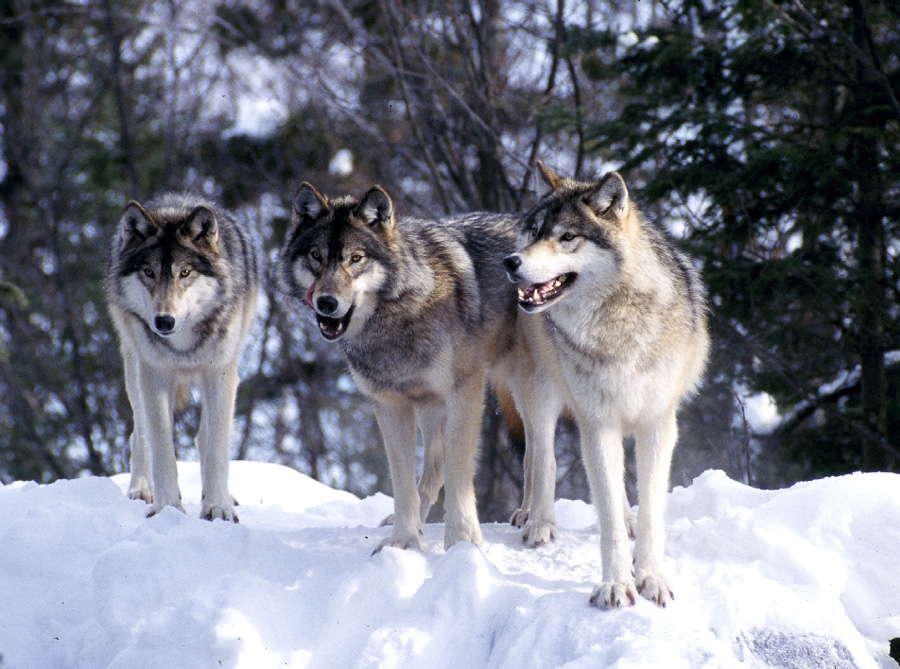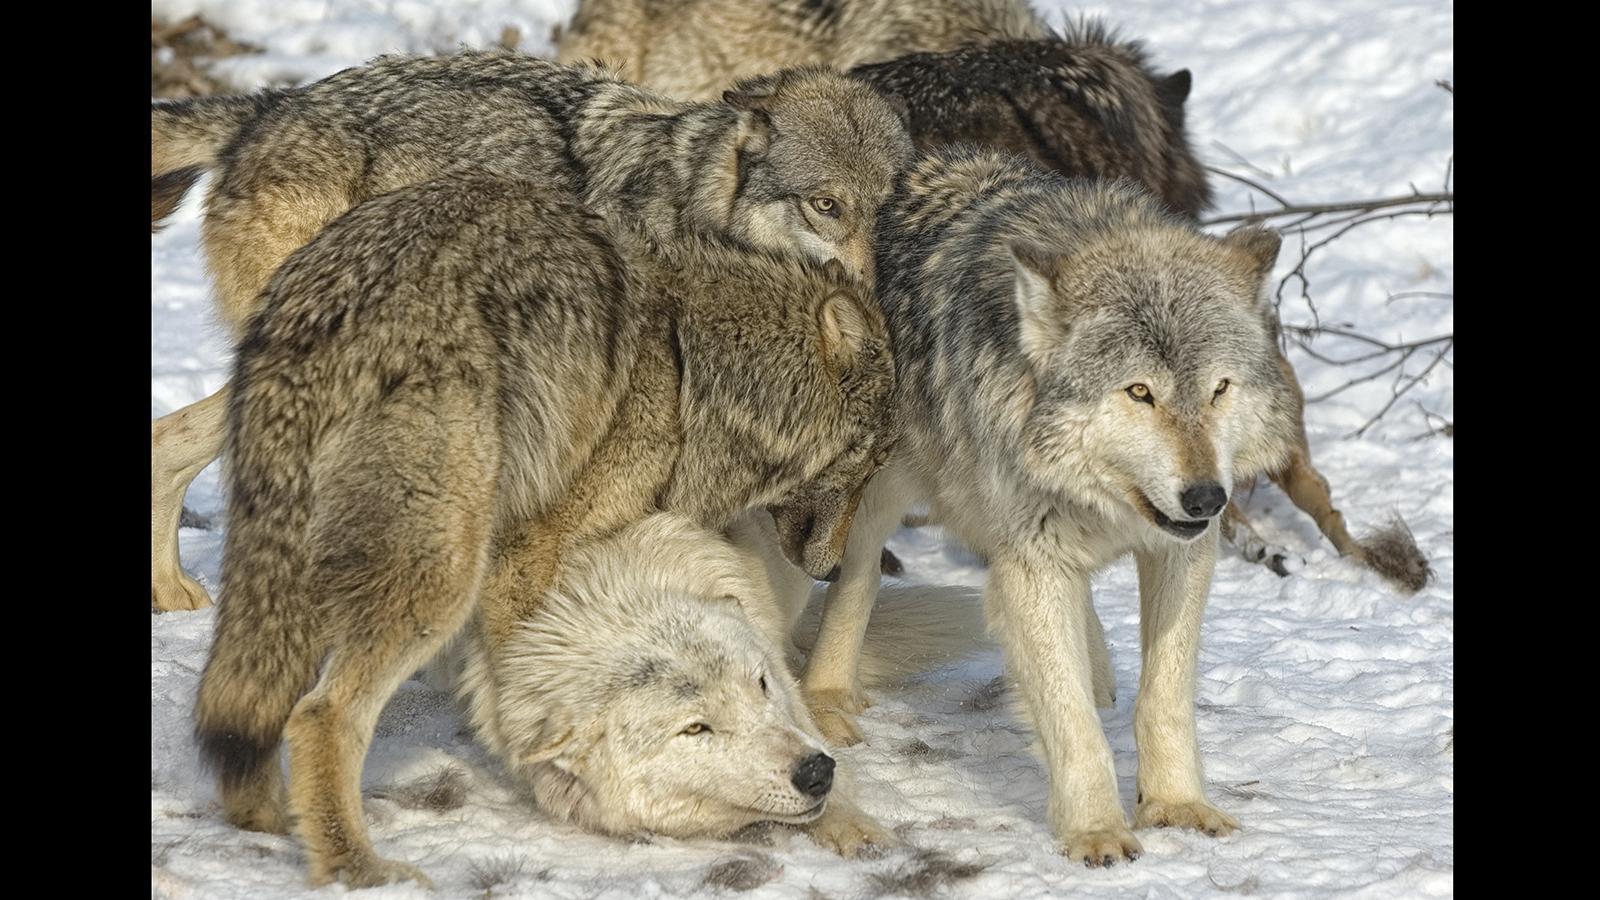The first image is the image on the left, the second image is the image on the right. For the images shown, is this caption "An image shows a horizontal row of exactly three wolves, and all are in similar poses." true? Answer yes or no. Yes. The first image is the image on the left, the second image is the image on the right. For the images displayed, is the sentence "The left image contains exactly three wolves." factually correct? Answer yes or no. Yes. 